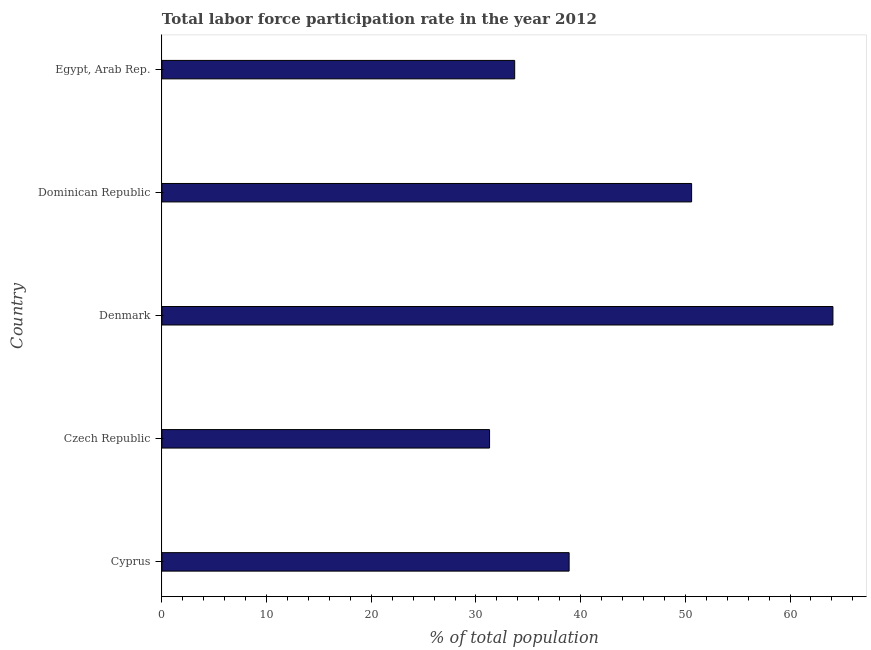Does the graph contain any zero values?
Offer a very short reply. No. What is the title of the graph?
Provide a succinct answer. Total labor force participation rate in the year 2012. What is the label or title of the X-axis?
Your answer should be very brief. % of total population. What is the total labor force participation rate in Dominican Republic?
Your answer should be compact. 50.6. Across all countries, what is the maximum total labor force participation rate?
Ensure brevity in your answer.  64.1. Across all countries, what is the minimum total labor force participation rate?
Make the answer very short. 31.3. In which country was the total labor force participation rate minimum?
Your answer should be very brief. Czech Republic. What is the sum of the total labor force participation rate?
Your answer should be compact. 218.6. What is the average total labor force participation rate per country?
Provide a succinct answer. 43.72. What is the median total labor force participation rate?
Offer a very short reply. 38.9. What is the ratio of the total labor force participation rate in Cyprus to that in Denmark?
Give a very brief answer. 0.61. What is the difference between the highest and the lowest total labor force participation rate?
Offer a very short reply. 32.8. In how many countries, is the total labor force participation rate greater than the average total labor force participation rate taken over all countries?
Keep it short and to the point. 2. What is the difference between two consecutive major ticks on the X-axis?
Make the answer very short. 10. Are the values on the major ticks of X-axis written in scientific E-notation?
Provide a succinct answer. No. What is the % of total population in Cyprus?
Offer a very short reply. 38.9. What is the % of total population of Czech Republic?
Keep it short and to the point. 31.3. What is the % of total population of Denmark?
Offer a very short reply. 64.1. What is the % of total population of Dominican Republic?
Provide a succinct answer. 50.6. What is the % of total population of Egypt, Arab Rep.?
Keep it short and to the point. 33.7. What is the difference between the % of total population in Cyprus and Czech Republic?
Provide a short and direct response. 7.6. What is the difference between the % of total population in Cyprus and Denmark?
Ensure brevity in your answer.  -25.2. What is the difference between the % of total population in Cyprus and Dominican Republic?
Provide a succinct answer. -11.7. What is the difference between the % of total population in Cyprus and Egypt, Arab Rep.?
Offer a terse response. 5.2. What is the difference between the % of total population in Czech Republic and Denmark?
Provide a short and direct response. -32.8. What is the difference between the % of total population in Czech Republic and Dominican Republic?
Provide a succinct answer. -19.3. What is the difference between the % of total population in Denmark and Egypt, Arab Rep.?
Offer a terse response. 30.4. What is the difference between the % of total population in Dominican Republic and Egypt, Arab Rep.?
Provide a short and direct response. 16.9. What is the ratio of the % of total population in Cyprus to that in Czech Republic?
Give a very brief answer. 1.24. What is the ratio of the % of total population in Cyprus to that in Denmark?
Offer a terse response. 0.61. What is the ratio of the % of total population in Cyprus to that in Dominican Republic?
Your answer should be very brief. 0.77. What is the ratio of the % of total population in Cyprus to that in Egypt, Arab Rep.?
Offer a terse response. 1.15. What is the ratio of the % of total population in Czech Republic to that in Denmark?
Keep it short and to the point. 0.49. What is the ratio of the % of total population in Czech Republic to that in Dominican Republic?
Offer a terse response. 0.62. What is the ratio of the % of total population in Czech Republic to that in Egypt, Arab Rep.?
Ensure brevity in your answer.  0.93. What is the ratio of the % of total population in Denmark to that in Dominican Republic?
Your answer should be compact. 1.27. What is the ratio of the % of total population in Denmark to that in Egypt, Arab Rep.?
Provide a succinct answer. 1.9. What is the ratio of the % of total population in Dominican Republic to that in Egypt, Arab Rep.?
Keep it short and to the point. 1.5. 